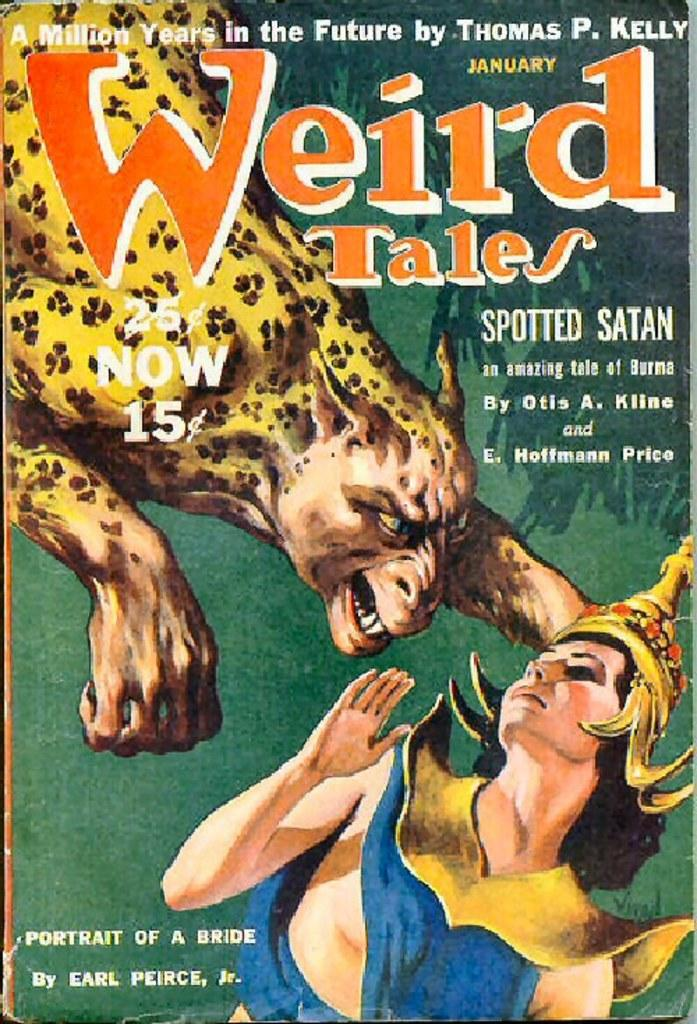<image>
Summarize the visual content of the image. The cover of a Weird Tales book has a hybrid animal attacking a woman. 